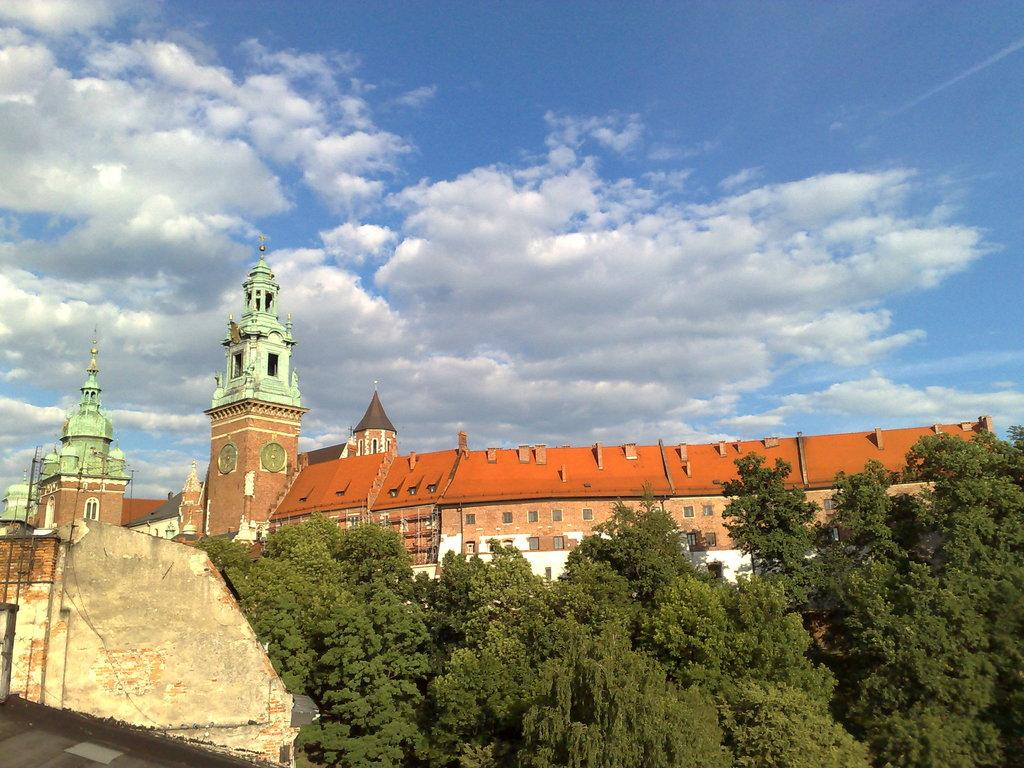What type of natural elements can be seen in the image? There are trees in the image. What type of man-made structures are present in the image? There are buildings in the image. What is visible in the background of the image? The sky is visible in the background of the image. What can be observed in the sky? Clouds are present in the sky. What direction is the balloon moving in the image? There is no balloon present in the image, so it cannot be determined which direction it might be moving. 